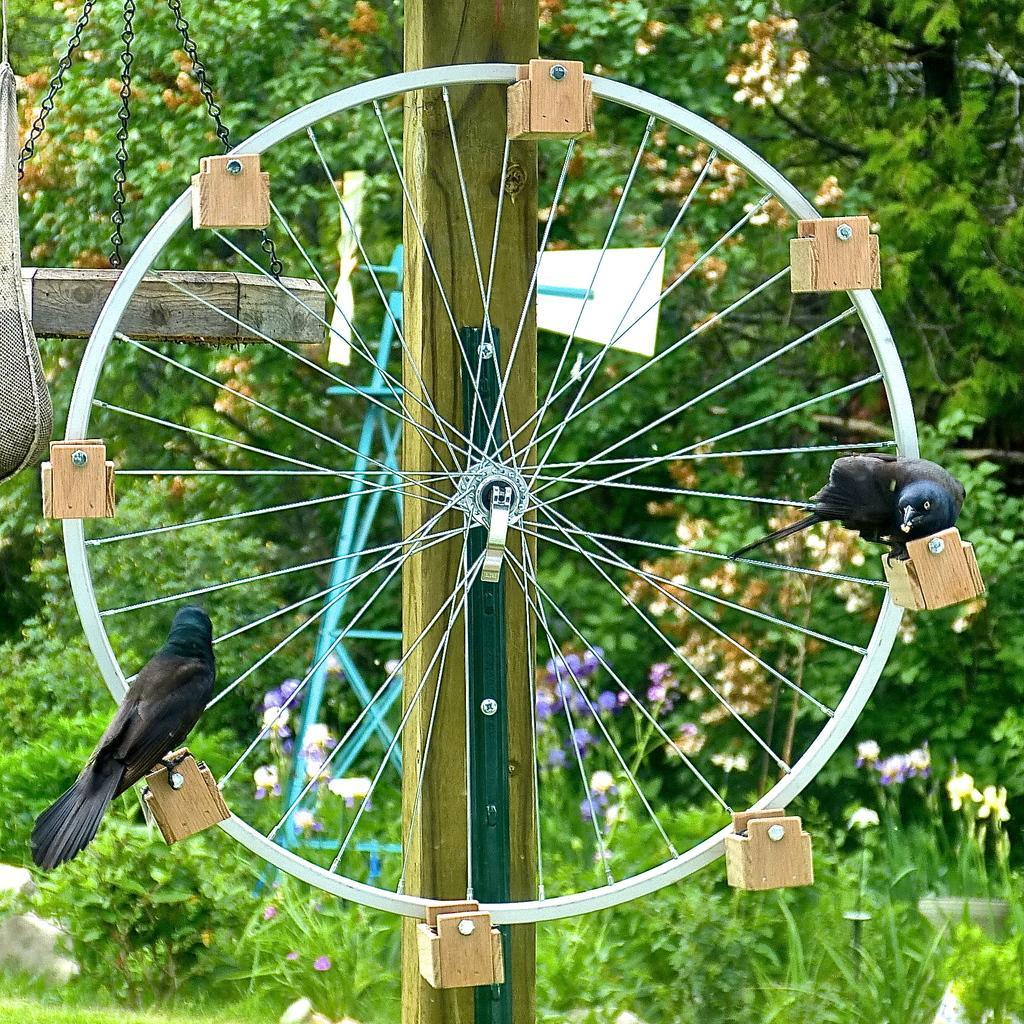What is the main subject in the center of the image? There is a wheel in the center of the image. What is attached to the wheel? There are wooden things and black color birds on the wheel. What can be seen in the background of the image? There are flowers, grass, and trees in the background of the image. What type of note is being played by the birds on the wheel in the image? There are no birds playing a note in the image; they are simply perched on the wheel. 